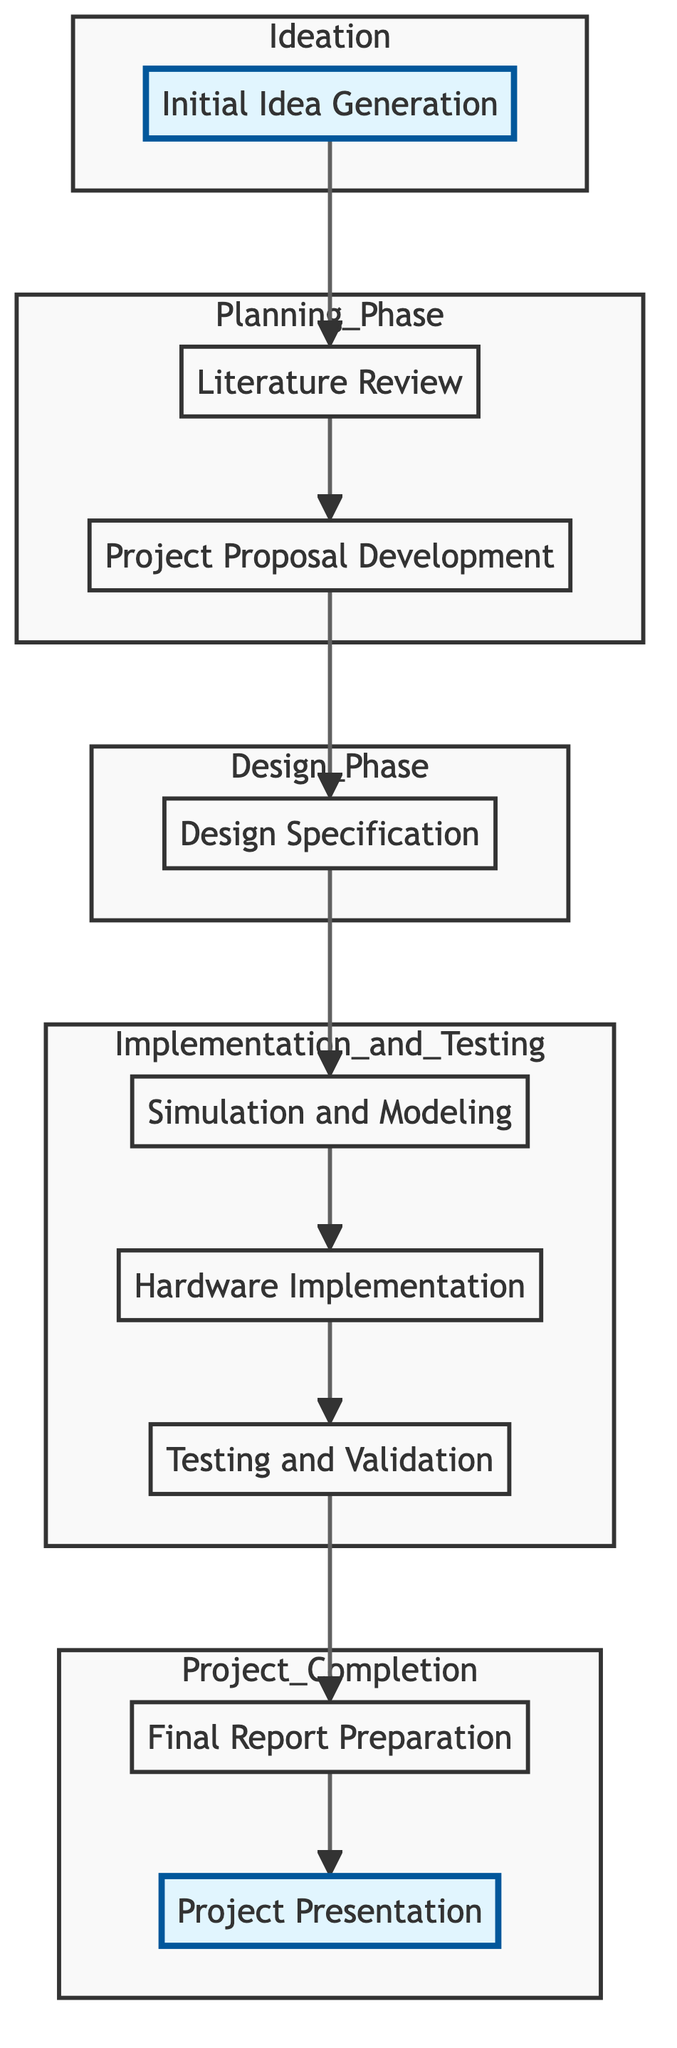What is the first step in the workflow? The first step is "Initial Idea Generation," which students undertake to brainstorm and outline their project ideas.
Answer: Initial Idea Generation How many phases are represented in the diagram? There are five distinct phases represented in the diagram: Ideation, Planning Phase, Design Phase, Implementation and Testing, and Project Completion.
Answer: Five What follows after the "Literature Review"? After the "Literature Review," the next step is "Project Proposal Development." This node represents the next task that students need to complete.
Answer: Project Proposal Development Which phase includes "Testing and Validation"? "Testing and Validation" is included in the "Implementation and Testing" phase, which encompasses all tasks related to executing and verifying the project's outcomes.
Answer: Implementation and Testing What is the final step in the workflow? The final step in the workflow is "Project Presentation," where students present their project findings to peers and faculty.
Answer: Project Presentation What is the relationship between "Simulation and Modeling" and "Hardware Implementation"? "Simulation and Modeling" precedes "Hardware Implementation," meaning students must first create simulations before they can fabricate the microprocessor.
Answer: Simulation and Modeling precedes Hardware Implementation Which two steps are part of the Project Completion phase? The two steps in the Project Completion phase are "Final Report Preparation" and "Project Presentation." This captures the last activities following the testing phase.
Answer: Final Report Preparation and Project Presentation What color highlights indicate the Ideation phase in the diagram? The Ideation phase is highlighted in a yellow color, which is represented as #ffecb3 in the styling of the diagram.
Answer: Yellow Which step comes immediately before "Final Report Preparation"? The step that comes immediately before "Final Report Preparation" is "Testing and Validation"; students must validate their design before preparing the final report.
Answer: Testing and Validation 